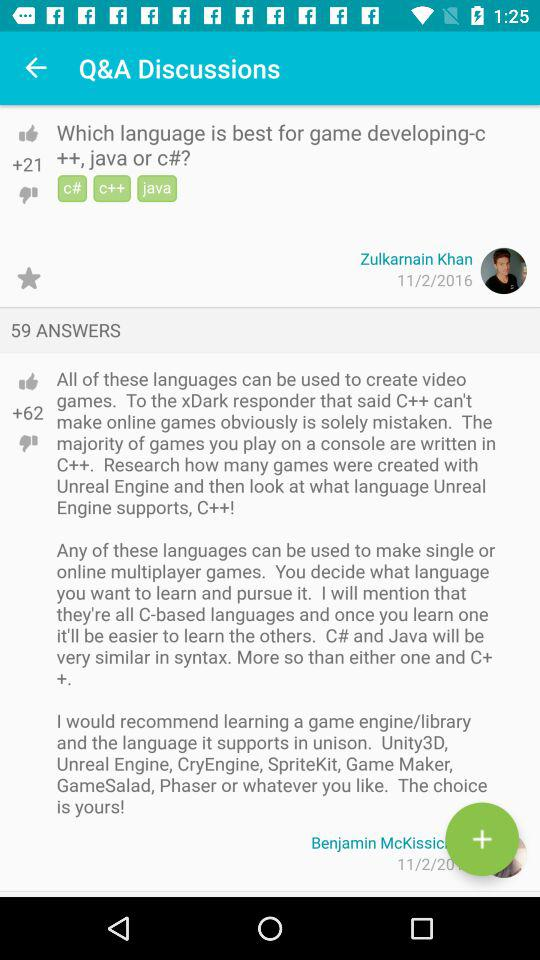How many answers are there? There are 59 answers. 